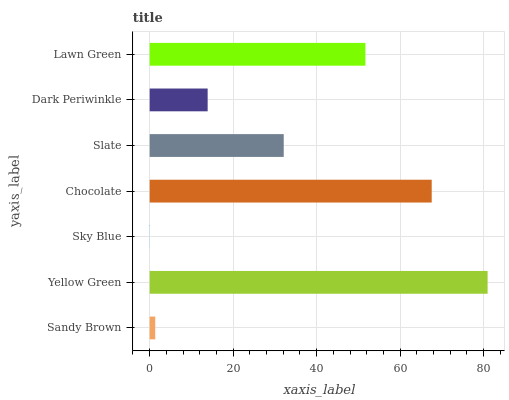Is Sky Blue the minimum?
Answer yes or no. Yes. Is Yellow Green the maximum?
Answer yes or no. Yes. Is Yellow Green the minimum?
Answer yes or no. No. Is Sky Blue the maximum?
Answer yes or no. No. Is Yellow Green greater than Sky Blue?
Answer yes or no. Yes. Is Sky Blue less than Yellow Green?
Answer yes or no. Yes. Is Sky Blue greater than Yellow Green?
Answer yes or no. No. Is Yellow Green less than Sky Blue?
Answer yes or no. No. Is Slate the high median?
Answer yes or no. Yes. Is Slate the low median?
Answer yes or no. Yes. Is Yellow Green the high median?
Answer yes or no. No. Is Sky Blue the low median?
Answer yes or no. No. 